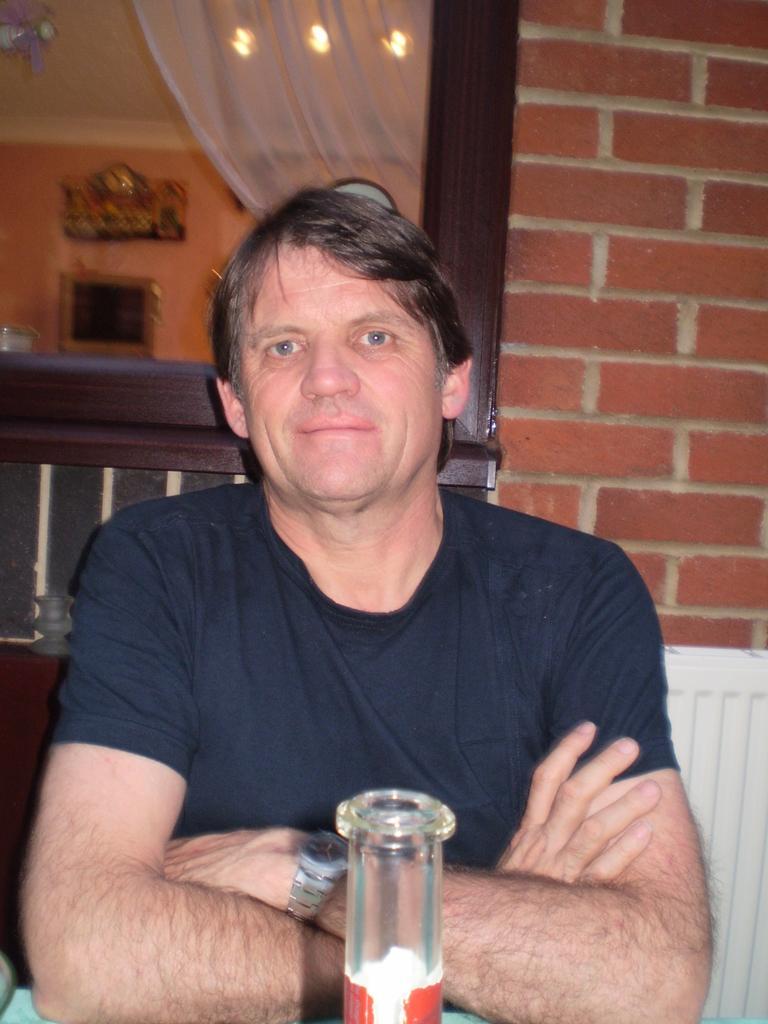Describe this image in one or two sentences. a man is sitting at a table in a restaurant. 